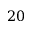Convert formula to latex. <formula><loc_0><loc_0><loc_500><loc_500>2 0</formula> 